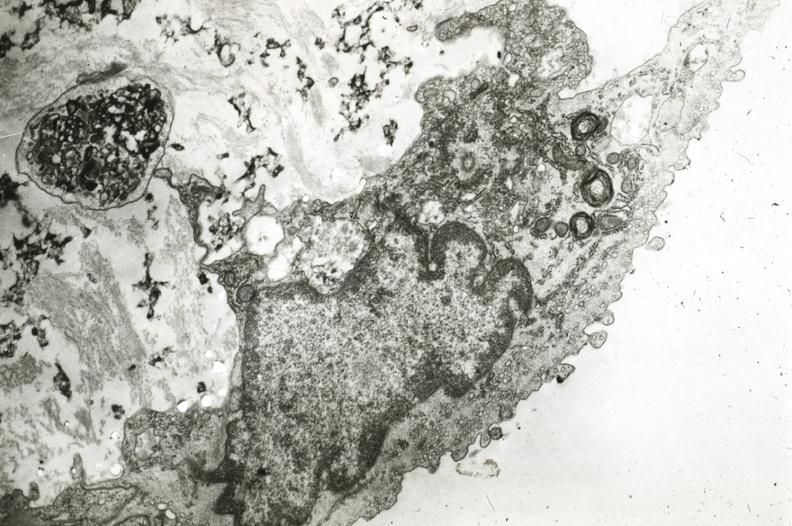what is present?
Answer the question using a single word or phrase. Coronary artery 